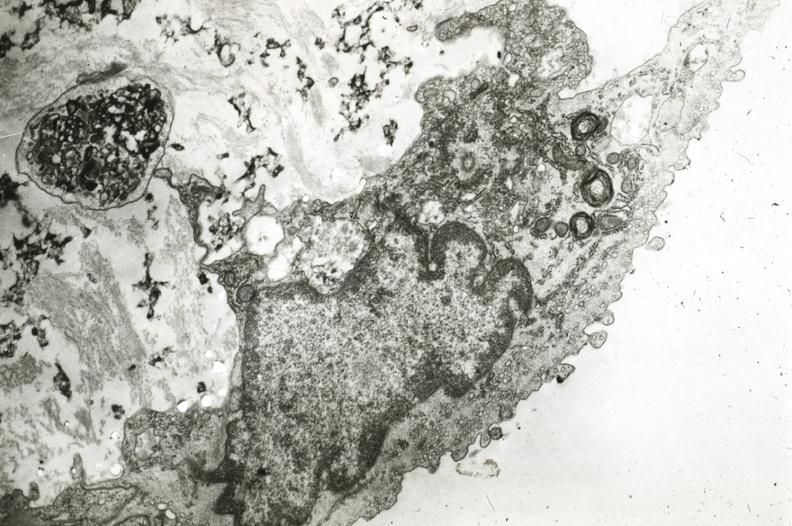what is present?
Answer the question using a single word or phrase. Coronary artery 